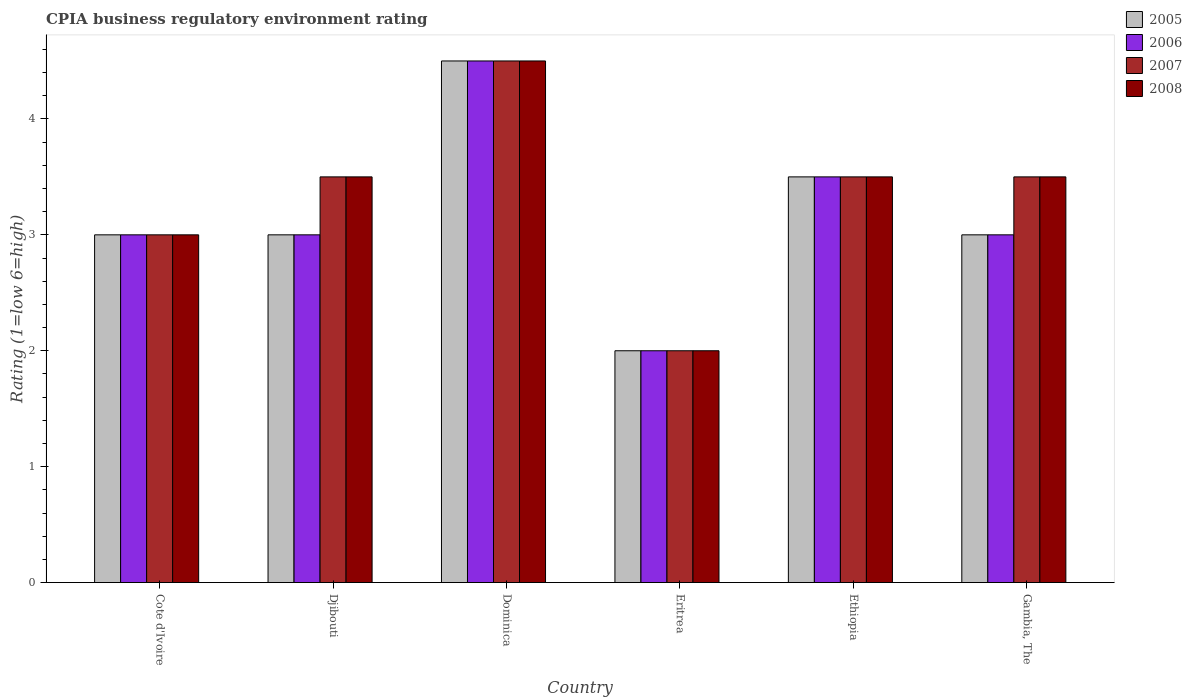How many bars are there on the 1st tick from the left?
Provide a succinct answer. 4. How many bars are there on the 1st tick from the right?
Provide a short and direct response. 4. What is the label of the 5th group of bars from the left?
Your answer should be compact. Ethiopia. What is the CPIA rating in 2006 in Djibouti?
Your answer should be compact. 3. Across all countries, what is the maximum CPIA rating in 2006?
Ensure brevity in your answer.  4.5. In which country was the CPIA rating in 2008 maximum?
Provide a short and direct response. Dominica. In which country was the CPIA rating in 2007 minimum?
Make the answer very short. Eritrea. What is the average CPIA rating in 2007 per country?
Keep it short and to the point. 3.33. What is the difference between the CPIA rating of/in 2007 and CPIA rating of/in 2008 in Ethiopia?
Your answer should be very brief. 0. In how many countries, is the CPIA rating in 2008 greater than 2?
Your answer should be compact. 5. What is the ratio of the CPIA rating in 2006 in Cote d'Ivoire to that in Gambia, The?
Your answer should be very brief. 1. Is the CPIA rating in 2005 in Djibouti less than that in Eritrea?
Provide a succinct answer. No. In how many countries, is the CPIA rating in 2006 greater than the average CPIA rating in 2006 taken over all countries?
Your answer should be very brief. 2. Is the sum of the CPIA rating in 2006 in Cote d'Ivoire and Gambia, The greater than the maximum CPIA rating in 2005 across all countries?
Make the answer very short. Yes. What does the 4th bar from the left in Cote d'Ivoire represents?
Offer a terse response. 2008. What does the 3rd bar from the right in Gambia, The represents?
Keep it short and to the point. 2006. Is it the case that in every country, the sum of the CPIA rating in 2007 and CPIA rating in 2008 is greater than the CPIA rating in 2006?
Give a very brief answer. Yes. Are all the bars in the graph horizontal?
Keep it short and to the point. No. Are the values on the major ticks of Y-axis written in scientific E-notation?
Offer a very short reply. No. Does the graph contain any zero values?
Offer a terse response. No. Does the graph contain grids?
Your answer should be compact. No. How many legend labels are there?
Give a very brief answer. 4. How are the legend labels stacked?
Offer a terse response. Vertical. What is the title of the graph?
Give a very brief answer. CPIA business regulatory environment rating. What is the label or title of the Y-axis?
Ensure brevity in your answer.  Rating (1=low 6=high). What is the Rating (1=low 6=high) in 2005 in Cote d'Ivoire?
Your response must be concise. 3. What is the Rating (1=low 6=high) of 2006 in Cote d'Ivoire?
Keep it short and to the point. 3. What is the Rating (1=low 6=high) of 2007 in Cote d'Ivoire?
Your answer should be compact. 3. What is the Rating (1=low 6=high) in 2008 in Cote d'Ivoire?
Provide a short and direct response. 3. What is the Rating (1=low 6=high) in 2006 in Djibouti?
Give a very brief answer. 3. What is the Rating (1=low 6=high) of 2007 in Djibouti?
Keep it short and to the point. 3.5. What is the Rating (1=low 6=high) of 2008 in Djibouti?
Your answer should be very brief. 3.5. What is the Rating (1=low 6=high) of 2005 in Dominica?
Give a very brief answer. 4.5. What is the Rating (1=low 6=high) of 2006 in Dominica?
Offer a terse response. 4.5. What is the Rating (1=low 6=high) of 2005 in Eritrea?
Give a very brief answer. 2. What is the Rating (1=low 6=high) in 2006 in Eritrea?
Your answer should be very brief. 2. What is the Rating (1=low 6=high) in 2007 in Ethiopia?
Offer a very short reply. 3.5. What is the Rating (1=low 6=high) in 2006 in Gambia, The?
Ensure brevity in your answer.  3. What is the Rating (1=low 6=high) of 2007 in Gambia, The?
Make the answer very short. 3.5. What is the Rating (1=low 6=high) in 2008 in Gambia, The?
Ensure brevity in your answer.  3.5. Across all countries, what is the minimum Rating (1=low 6=high) in 2008?
Provide a short and direct response. 2. What is the total Rating (1=low 6=high) of 2005 in the graph?
Provide a succinct answer. 19. What is the total Rating (1=low 6=high) of 2006 in the graph?
Your response must be concise. 19. What is the total Rating (1=low 6=high) of 2007 in the graph?
Give a very brief answer. 20. What is the total Rating (1=low 6=high) of 2008 in the graph?
Provide a succinct answer. 20. What is the difference between the Rating (1=low 6=high) of 2005 in Cote d'Ivoire and that in Djibouti?
Make the answer very short. 0. What is the difference between the Rating (1=low 6=high) in 2007 in Cote d'Ivoire and that in Djibouti?
Ensure brevity in your answer.  -0.5. What is the difference between the Rating (1=low 6=high) in 2008 in Cote d'Ivoire and that in Djibouti?
Ensure brevity in your answer.  -0.5. What is the difference between the Rating (1=low 6=high) of 2005 in Cote d'Ivoire and that in Dominica?
Your response must be concise. -1.5. What is the difference between the Rating (1=low 6=high) of 2006 in Cote d'Ivoire and that in Dominica?
Offer a very short reply. -1.5. What is the difference between the Rating (1=low 6=high) of 2007 in Cote d'Ivoire and that in Dominica?
Provide a short and direct response. -1.5. What is the difference between the Rating (1=low 6=high) of 2005 in Cote d'Ivoire and that in Eritrea?
Your answer should be very brief. 1. What is the difference between the Rating (1=low 6=high) of 2005 in Cote d'Ivoire and that in Ethiopia?
Keep it short and to the point. -0.5. What is the difference between the Rating (1=low 6=high) of 2008 in Cote d'Ivoire and that in Ethiopia?
Make the answer very short. -0.5. What is the difference between the Rating (1=low 6=high) in 2006 in Cote d'Ivoire and that in Gambia, The?
Provide a short and direct response. 0. What is the difference between the Rating (1=low 6=high) of 2007 in Cote d'Ivoire and that in Gambia, The?
Ensure brevity in your answer.  -0.5. What is the difference between the Rating (1=low 6=high) in 2008 in Cote d'Ivoire and that in Gambia, The?
Your answer should be very brief. -0.5. What is the difference between the Rating (1=low 6=high) of 2007 in Djibouti and that in Eritrea?
Provide a succinct answer. 1.5. What is the difference between the Rating (1=low 6=high) in 2005 in Djibouti and that in Ethiopia?
Your answer should be compact. -0.5. What is the difference between the Rating (1=low 6=high) in 2006 in Djibouti and that in Ethiopia?
Make the answer very short. -0.5. What is the difference between the Rating (1=low 6=high) of 2008 in Djibouti and that in Ethiopia?
Provide a short and direct response. 0. What is the difference between the Rating (1=low 6=high) in 2006 in Djibouti and that in Gambia, The?
Make the answer very short. 0. What is the difference between the Rating (1=low 6=high) in 2006 in Dominica and that in Eritrea?
Provide a short and direct response. 2.5. What is the difference between the Rating (1=low 6=high) of 2007 in Dominica and that in Eritrea?
Keep it short and to the point. 2.5. What is the difference between the Rating (1=low 6=high) of 2008 in Dominica and that in Eritrea?
Give a very brief answer. 2.5. What is the difference between the Rating (1=low 6=high) of 2005 in Dominica and that in Ethiopia?
Offer a very short reply. 1. What is the difference between the Rating (1=low 6=high) in 2006 in Dominica and that in Ethiopia?
Offer a terse response. 1. What is the difference between the Rating (1=low 6=high) in 2008 in Dominica and that in Ethiopia?
Your answer should be very brief. 1. What is the difference between the Rating (1=low 6=high) in 2005 in Dominica and that in Gambia, The?
Offer a very short reply. 1.5. What is the difference between the Rating (1=low 6=high) in 2006 in Dominica and that in Gambia, The?
Ensure brevity in your answer.  1.5. What is the difference between the Rating (1=low 6=high) in 2008 in Eritrea and that in Ethiopia?
Offer a terse response. -1.5. What is the difference between the Rating (1=low 6=high) in 2006 in Eritrea and that in Gambia, The?
Your answer should be compact. -1. What is the difference between the Rating (1=low 6=high) in 2008 in Eritrea and that in Gambia, The?
Your answer should be very brief. -1.5. What is the difference between the Rating (1=low 6=high) of 2006 in Ethiopia and that in Gambia, The?
Provide a succinct answer. 0.5. What is the difference between the Rating (1=low 6=high) in 2007 in Ethiopia and that in Gambia, The?
Your answer should be compact. 0. What is the difference between the Rating (1=low 6=high) of 2005 in Cote d'Ivoire and the Rating (1=low 6=high) of 2006 in Djibouti?
Your answer should be compact. 0. What is the difference between the Rating (1=low 6=high) of 2006 in Cote d'Ivoire and the Rating (1=low 6=high) of 2007 in Djibouti?
Make the answer very short. -0.5. What is the difference between the Rating (1=low 6=high) of 2005 in Cote d'Ivoire and the Rating (1=low 6=high) of 2006 in Dominica?
Make the answer very short. -1.5. What is the difference between the Rating (1=low 6=high) in 2005 in Cote d'Ivoire and the Rating (1=low 6=high) in 2007 in Dominica?
Your response must be concise. -1.5. What is the difference between the Rating (1=low 6=high) in 2005 in Cote d'Ivoire and the Rating (1=low 6=high) in 2008 in Dominica?
Keep it short and to the point. -1.5. What is the difference between the Rating (1=low 6=high) in 2006 in Cote d'Ivoire and the Rating (1=low 6=high) in 2007 in Dominica?
Offer a terse response. -1.5. What is the difference between the Rating (1=low 6=high) of 2006 in Cote d'Ivoire and the Rating (1=low 6=high) of 2008 in Dominica?
Provide a succinct answer. -1.5. What is the difference between the Rating (1=low 6=high) in 2005 in Cote d'Ivoire and the Rating (1=low 6=high) in 2006 in Eritrea?
Offer a terse response. 1. What is the difference between the Rating (1=low 6=high) in 2005 in Cote d'Ivoire and the Rating (1=low 6=high) in 2007 in Eritrea?
Offer a terse response. 1. What is the difference between the Rating (1=low 6=high) in 2007 in Cote d'Ivoire and the Rating (1=low 6=high) in 2008 in Eritrea?
Your answer should be very brief. 1. What is the difference between the Rating (1=low 6=high) of 2005 in Cote d'Ivoire and the Rating (1=low 6=high) of 2006 in Ethiopia?
Give a very brief answer. -0.5. What is the difference between the Rating (1=low 6=high) of 2005 in Cote d'Ivoire and the Rating (1=low 6=high) of 2007 in Ethiopia?
Provide a short and direct response. -0.5. What is the difference between the Rating (1=low 6=high) of 2005 in Cote d'Ivoire and the Rating (1=low 6=high) of 2008 in Ethiopia?
Make the answer very short. -0.5. What is the difference between the Rating (1=low 6=high) in 2006 in Cote d'Ivoire and the Rating (1=low 6=high) in 2008 in Ethiopia?
Keep it short and to the point. -0.5. What is the difference between the Rating (1=low 6=high) in 2007 in Cote d'Ivoire and the Rating (1=low 6=high) in 2008 in Ethiopia?
Provide a short and direct response. -0.5. What is the difference between the Rating (1=low 6=high) of 2005 in Cote d'Ivoire and the Rating (1=low 6=high) of 2006 in Gambia, The?
Ensure brevity in your answer.  0. What is the difference between the Rating (1=low 6=high) in 2005 in Cote d'Ivoire and the Rating (1=low 6=high) in 2007 in Gambia, The?
Ensure brevity in your answer.  -0.5. What is the difference between the Rating (1=low 6=high) in 2006 in Cote d'Ivoire and the Rating (1=low 6=high) in 2008 in Gambia, The?
Ensure brevity in your answer.  -0.5. What is the difference between the Rating (1=low 6=high) in 2007 in Djibouti and the Rating (1=low 6=high) in 2008 in Dominica?
Offer a very short reply. -1. What is the difference between the Rating (1=low 6=high) of 2005 in Djibouti and the Rating (1=low 6=high) of 2006 in Eritrea?
Provide a short and direct response. 1. What is the difference between the Rating (1=low 6=high) of 2005 in Djibouti and the Rating (1=low 6=high) of 2007 in Eritrea?
Offer a terse response. 1. What is the difference between the Rating (1=low 6=high) of 2005 in Djibouti and the Rating (1=low 6=high) of 2008 in Eritrea?
Your response must be concise. 1. What is the difference between the Rating (1=low 6=high) in 2006 in Djibouti and the Rating (1=low 6=high) in 2007 in Eritrea?
Your answer should be compact. 1. What is the difference between the Rating (1=low 6=high) in 2006 in Djibouti and the Rating (1=low 6=high) in 2008 in Eritrea?
Keep it short and to the point. 1. What is the difference between the Rating (1=low 6=high) of 2007 in Djibouti and the Rating (1=low 6=high) of 2008 in Eritrea?
Offer a terse response. 1.5. What is the difference between the Rating (1=low 6=high) in 2005 in Djibouti and the Rating (1=low 6=high) in 2008 in Gambia, The?
Your answer should be very brief. -0.5. What is the difference between the Rating (1=low 6=high) of 2006 in Djibouti and the Rating (1=low 6=high) of 2008 in Gambia, The?
Offer a terse response. -0.5. What is the difference between the Rating (1=low 6=high) in 2007 in Djibouti and the Rating (1=low 6=high) in 2008 in Gambia, The?
Keep it short and to the point. 0. What is the difference between the Rating (1=low 6=high) in 2006 in Dominica and the Rating (1=low 6=high) in 2007 in Eritrea?
Keep it short and to the point. 2.5. What is the difference between the Rating (1=low 6=high) of 2006 in Dominica and the Rating (1=low 6=high) of 2008 in Eritrea?
Offer a terse response. 2.5. What is the difference between the Rating (1=low 6=high) in 2005 in Dominica and the Rating (1=low 6=high) in 2006 in Ethiopia?
Your response must be concise. 1. What is the difference between the Rating (1=low 6=high) of 2007 in Dominica and the Rating (1=low 6=high) of 2008 in Ethiopia?
Provide a succinct answer. 1. What is the difference between the Rating (1=low 6=high) of 2005 in Dominica and the Rating (1=low 6=high) of 2006 in Gambia, The?
Ensure brevity in your answer.  1.5. What is the difference between the Rating (1=low 6=high) in 2006 in Dominica and the Rating (1=low 6=high) in 2007 in Gambia, The?
Give a very brief answer. 1. What is the difference between the Rating (1=low 6=high) of 2007 in Dominica and the Rating (1=low 6=high) of 2008 in Gambia, The?
Give a very brief answer. 1. What is the difference between the Rating (1=low 6=high) in 2005 in Eritrea and the Rating (1=low 6=high) in 2006 in Ethiopia?
Give a very brief answer. -1.5. What is the difference between the Rating (1=low 6=high) of 2006 in Eritrea and the Rating (1=low 6=high) of 2007 in Ethiopia?
Offer a terse response. -1.5. What is the difference between the Rating (1=low 6=high) of 2006 in Eritrea and the Rating (1=low 6=high) of 2008 in Ethiopia?
Provide a succinct answer. -1.5. What is the difference between the Rating (1=low 6=high) in 2007 in Eritrea and the Rating (1=low 6=high) in 2008 in Ethiopia?
Make the answer very short. -1.5. What is the difference between the Rating (1=low 6=high) of 2005 in Eritrea and the Rating (1=low 6=high) of 2007 in Gambia, The?
Your answer should be compact. -1.5. What is the difference between the Rating (1=low 6=high) of 2005 in Eritrea and the Rating (1=low 6=high) of 2008 in Gambia, The?
Offer a terse response. -1.5. What is the difference between the Rating (1=low 6=high) of 2006 in Eritrea and the Rating (1=low 6=high) of 2008 in Gambia, The?
Make the answer very short. -1.5. What is the difference between the Rating (1=low 6=high) in 2007 in Eritrea and the Rating (1=low 6=high) in 2008 in Gambia, The?
Ensure brevity in your answer.  -1.5. What is the difference between the Rating (1=low 6=high) of 2005 in Ethiopia and the Rating (1=low 6=high) of 2006 in Gambia, The?
Your answer should be compact. 0.5. What is the difference between the Rating (1=low 6=high) in 2007 in Ethiopia and the Rating (1=low 6=high) in 2008 in Gambia, The?
Your answer should be compact. 0. What is the average Rating (1=low 6=high) of 2005 per country?
Your response must be concise. 3.17. What is the average Rating (1=low 6=high) in 2006 per country?
Your response must be concise. 3.17. What is the average Rating (1=low 6=high) in 2008 per country?
Give a very brief answer. 3.33. What is the difference between the Rating (1=low 6=high) in 2005 and Rating (1=low 6=high) in 2008 in Cote d'Ivoire?
Provide a succinct answer. 0. What is the difference between the Rating (1=low 6=high) in 2007 and Rating (1=low 6=high) in 2008 in Cote d'Ivoire?
Keep it short and to the point. 0. What is the difference between the Rating (1=low 6=high) in 2005 and Rating (1=low 6=high) in 2006 in Djibouti?
Keep it short and to the point. 0. What is the difference between the Rating (1=low 6=high) in 2007 and Rating (1=low 6=high) in 2008 in Djibouti?
Provide a short and direct response. 0. What is the difference between the Rating (1=low 6=high) in 2005 and Rating (1=low 6=high) in 2006 in Dominica?
Offer a very short reply. 0. What is the difference between the Rating (1=low 6=high) of 2005 and Rating (1=low 6=high) of 2007 in Dominica?
Ensure brevity in your answer.  0. What is the difference between the Rating (1=low 6=high) of 2006 and Rating (1=low 6=high) of 2007 in Dominica?
Provide a succinct answer. 0. What is the difference between the Rating (1=low 6=high) of 2005 and Rating (1=low 6=high) of 2006 in Eritrea?
Make the answer very short. 0. What is the difference between the Rating (1=low 6=high) of 2007 and Rating (1=low 6=high) of 2008 in Eritrea?
Your answer should be compact. 0. What is the difference between the Rating (1=low 6=high) of 2005 and Rating (1=low 6=high) of 2007 in Ethiopia?
Your answer should be very brief. 0. What is the difference between the Rating (1=low 6=high) in 2005 and Rating (1=low 6=high) in 2008 in Ethiopia?
Make the answer very short. 0. What is the difference between the Rating (1=low 6=high) of 2007 and Rating (1=low 6=high) of 2008 in Ethiopia?
Offer a terse response. 0. What is the difference between the Rating (1=low 6=high) of 2005 and Rating (1=low 6=high) of 2006 in Gambia, The?
Your answer should be very brief. 0. What is the difference between the Rating (1=low 6=high) in 2005 and Rating (1=low 6=high) in 2007 in Gambia, The?
Offer a terse response. -0.5. What is the difference between the Rating (1=low 6=high) of 2005 and Rating (1=low 6=high) of 2008 in Gambia, The?
Your response must be concise. -0.5. What is the difference between the Rating (1=low 6=high) of 2006 and Rating (1=low 6=high) of 2007 in Gambia, The?
Your answer should be compact. -0.5. What is the difference between the Rating (1=low 6=high) of 2006 and Rating (1=low 6=high) of 2008 in Gambia, The?
Ensure brevity in your answer.  -0.5. What is the ratio of the Rating (1=low 6=high) in 2007 in Cote d'Ivoire to that in Djibouti?
Your answer should be compact. 0.86. What is the ratio of the Rating (1=low 6=high) of 2005 in Cote d'Ivoire to that in Dominica?
Keep it short and to the point. 0.67. What is the ratio of the Rating (1=low 6=high) in 2006 in Cote d'Ivoire to that in Dominica?
Your answer should be compact. 0.67. What is the ratio of the Rating (1=low 6=high) of 2008 in Cote d'Ivoire to that in Dominica?
Provide a succinct answer. 0.67. What is the ratio of the Rating (1=low 6=high) of 2005 in Cote d'Ivoire to that in Eritrea?
Ensure brevity in your answer.  1.5. What is the ratio of the Rating (1=low 6=high) in 2007 in Cote d'Ivoire to that in Ethiopia?
Provide a short and direct response. 0.86. What is the ratio of the Rating (1=low 6=high) in 2008 in Cote d'Ivoire to that in Ethiopia?
Make the answer very short. 0.86. What is the ratio of the Rating (1=low 6=high) of 2005 in Cote d'Ivoire to that in Gambia, The?
Give a very brief answer. 1. What is the ratio of the Rating (1=low 6=high) in 2007 in Cote d'Ivoire to that in Gambia, The?
Your answer should be compact. 0.86. What is the ratio of the Rating (1=low 6=high) of 2006 in Djibouti to that in Dominica?
Keep it short and to the point. 0.67. What is the ratio of the Rating (1=low 6=high) in 2007 in Djibouti to that in Dominica?
Provide a succinct answer. 0.78. What is the ratio of the Rating (1=low 6=high) in 2008 in Djibouti to that in Dominica?
Ensure brevity in your answer.  0.78. What is the ratio of the Rating (1=low 6=high) of 2006 in Djibouti to that in Eritrea?
Your answer should be very brief. 1.5. What is the ratio of the Rating (1=low 6=high) in 2007 in Djibouti to that in Eritrea?
Your answer should be compact. 1.75. What is the ratio of the Rating (1=low 6=high) in 2008 in Djibouti to that in Eritrea?
Offer a terse response. 1.75. What is the ratio of the Rating (1=low 6=high) of 2005 in Djibouti to that in Ethiopia?
Provide a succinct answer. 0.86. What is the ratio of the Rating (1=low 6=high) in 2007 in Djibouti to that in Ethiopia?
Your answer should be very brief. 1. What is the ratio of the Rating (1=low 6=high) in 2008 in Djibouti to that in Ethiopia?
Your answer should be compact. 1. What is the ratio of the Rating (1=low 6=high) of 2006 in Djibouti to that in Gambia, The?
Your response must be concise. 1. What is the ratio of the Rating (1=low 6=high) of 2008 in Djibouti to that in Gambia, The?
Keep it short and to the point. 1. What is the ratio of the Rating (1=low 6=high) of 2005 in Dominica to that in Eritrea?
Keep it short and to the point. 2.25. What is the ratio of the Rating (1=low 6=high) in 2006 in Dominica to that in Eritrea?
Provide a succinct answer. 2.25. What is the ratio of the Rating (1=low 6=high) in 2007 in Dominica to that in Eritrea?
Offer a terse response. 2.25. What is the ratio of the Rating (1=low 6=high) in 2008 in Dominica to that in Eritrea?
Give a very brief answer. 2.25. What is the ratio of the Rating (1=low 6=high) in 2006 in Dominica to that in Ethiopia?
Offer a very short reply. 1.29. What is the ratio of the Rating (1=low 6=high) of 2008 in Dominica to that in Ethiopia?
Offer a terse response. 1.29. What is the ratio of the Rating (1=low 6=high) of 2006 in Dominica to that in Gambia, The?
Your answer should be compact. 1.5. What is the ratio of the Rating (1=low 6=high) in 2008 in Eritrea to that in Ethiopia?
Offer a very short reply. 0.57. What is the ratio of the Rating (1=low 6=high) in 2005 in Eritrea to that in Gambia, The?
Your answer should be very brief. 0.67. What is the ratio of the Rating (1=low 6=high) of 2007 in Eritrea to that in Gambia, The?
Ensure brevity in your answer.  0.57. What is the ratio of the Rating (1=low 6=high) in 2008 in Eritrea to that in Gambia, The?
Your answer should be compact. 0.57. What is the ratio of the Rating (1=low 6=high) of 2005 in Ethiopia to that in Gambia, The?
Offer a very short reply. 1.17. What is the ratio of the Rating (1=low 6=high) in 2006 in Ethiopia to that in Gambia, The?
Give a very brief answer. 1.17. What is the ratio of the Rating (1=low 6=high) of 2007 in Ethiopia to that in Gambia, The?
Provide a short and direct response. 1. What is the difference between the highest and the second highest Rating (1=low 6=high) of 2005?
Keep it short and to the point. 1. What is the difference between the highest and the second highest Rating (1=low 6=high) of 2006?
Your answer should be very brief. 1. What is the difference between the highest and the second highest Rating (1=low 6=high) of 2007?
Offer a very short reply. 1. What is the difference between the highest and the second highest Rating (1=low 6=high) in 2008?
Give a very brief answer. 1. What is the difference between the highest and the lowest Rating (1=low 6=high) in 2005?
Your answer should be compact. 2.5. 